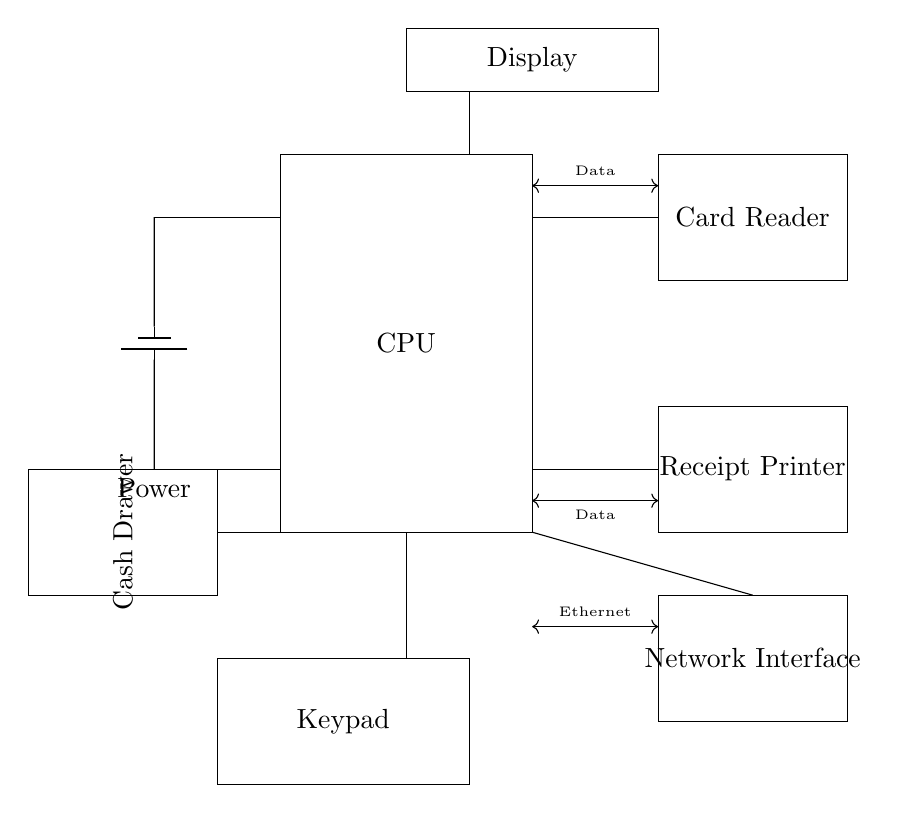What is the main processing unit called? The main processing unit is labeled as "CPU" in the rectangle at the origin of the diagram.
Answer: CPU How many components are there in this circuit? The circuit diagram visually depicts six main components: CPU, Card Reader, Receipt Printer, Display, Keypad, and Network Interface.
Answer: Six Which component connects to the cash drawer? The cash drawer connects to the CPU, as indicated by a direct line from the CPU to the cash drawer labeled as "Cash Drawer."
Answer: CPU What type of data connection is between the receipt printer and the CPU? The data connection is labeled as a type of "Data" line running from the CPU to the Receipt Printer.
Answer: Data Where is the power supply located? The power supply is indicated on the left side of the diagram, with a battery symbol located at coordinates (-2,5) to (-2,1).
Answer: Left side How does the network interface connect to the rest of the circuit? The network interface connects to the CPU through an "Ethernet" connection, shown as a line labeled "Ethernet" between the CPU and the Network Interface.
Answer: Ethernet What is displayed above the CPU? Above the CPU, there is a rectangle labeled "Display," indicating it is a visual output component in the circuit.
Answer: Display 